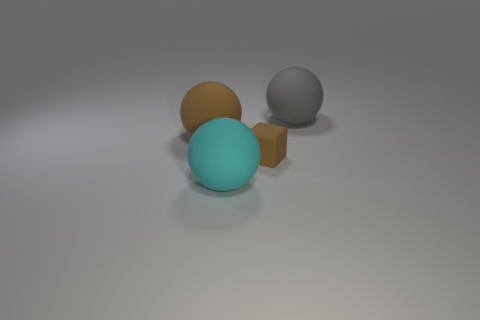Add 3 cyan objects. How many objects exist? 7 Subtract all balls. How many objects are left? 1 Subtract all cyan spheres. Subtract all big rubber things. How many objects are left? 0 Add 2 large gray rubber things. How many large gray rubber things are left? 3 Add 1 tiny matte things. How many tiny matte things exist? 2 Subtract 0 purple blocks. How many objects are left? 4 